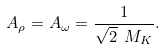Convert formula to latex. <formula><loc_0><loc_0><loc_500><loc_500>A _ { \rho } = A _ { \omega } = { \frac { 1 } { \sqrt { 2 } \ M _ { K } } } .</formula> 